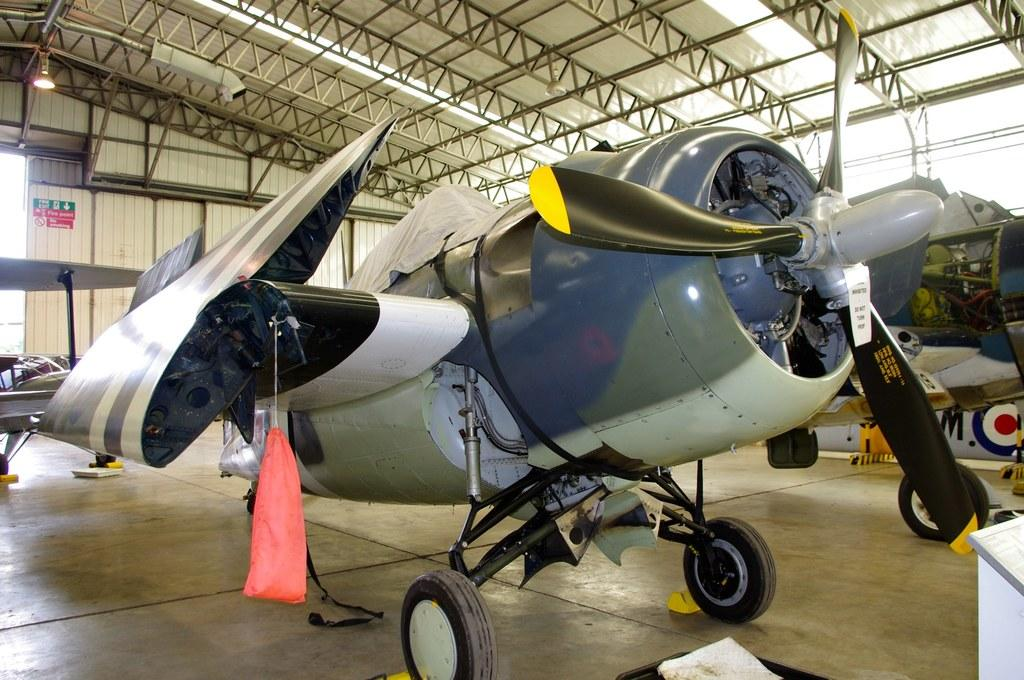What is the main subject in the center of the image? There is an airplane in the center of the image. What can be seen at the top side of the image? There is a roof at the top side of the image. Are there any other airplanes visible in the image? Yes, there is another airplane on the right side of the image. What type of meal is being prepared in the image? There is no meal preparation visible in the image; it primarily features airplanes and a roof. Can you describe the clouds in the image? There are no clouds visible in the image. 